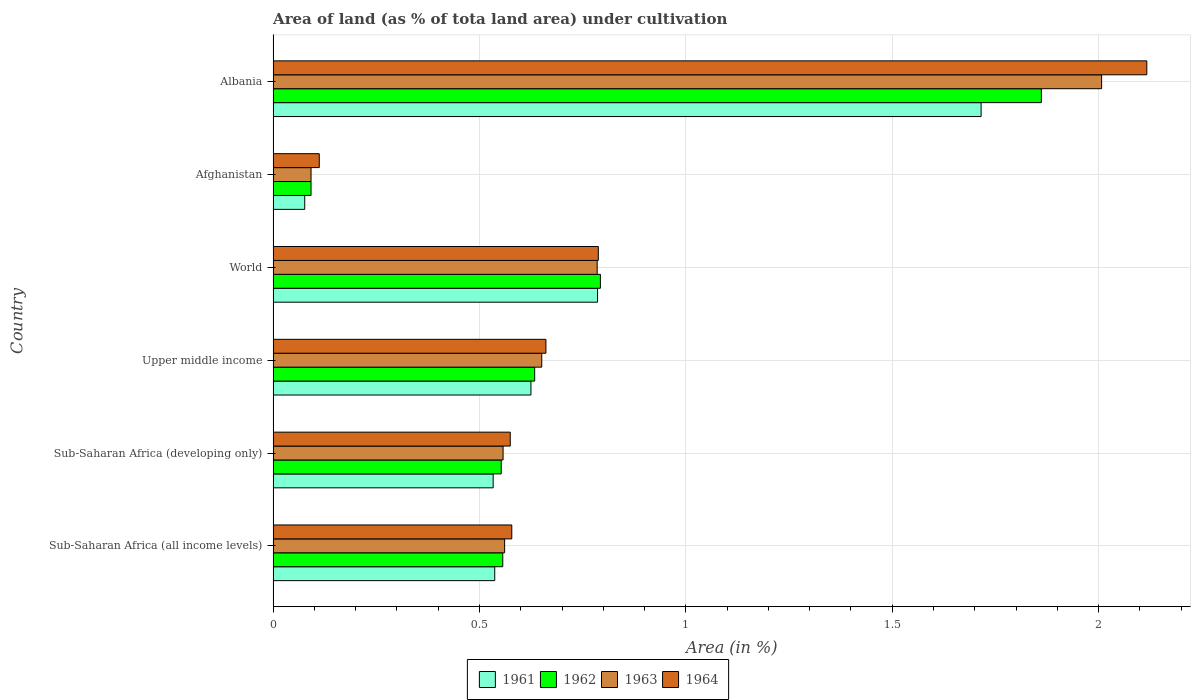How many different coloured bars are there?
Give a very brief answer. 4. Are the number of bars per tick equal to the number of legend labels?
Provide a succinct answer. Yes. Are the number of bars on each tick of the Y-axis equal?
Provide a succinct answer. Yes. What is the label of the 2nd group of bars from the top?
Your answer should be compact. Afghanistan. What is the percentage of land under cultivation in 1961 in Albania?
Give a very brief answer. 1.72. Across all countries, what is the maximum percentage of land under cultivation in 1961?
Provide a short and direct response. 1.72. Across all countries, what is the minimum percentage of land under cultivation in 1964?
Your answer should be very brief. 0.11. In which country was the percentage of land under cultivation in 1962 maximum?
Make the answer very short. Albania. In which country was the percentage of land under cultivation in 1964 minimum?
Give a very brief answer. Afghanistan. What is the total percentage of land under cultivation in 1964 in the graph?
Offer a very short reply. 4.83. What is the difference between the percentage of land under cultivation in 1961 in Albania and that in Sub-Saharan Africa (all income levels)?
Provide a short and direct response. 1.18. What is the difference between the percentage of land under cultivation in 1961 in Sub-Saharan Africa (all income levels) and the percentage of land under cultivation in 1962 in Sub-Saharan Africa (developing only)?
Offer a terse response. -0.02. What is the average percentage of land under cultivation in 1961 per country?
Provide a short and direct response. 0.71. What is the difference between the percentage of land under cultivation in 1961 and percentage of land under cultivation in 1963 in Afghanistan?
Keep it short and to the point. -0.02. What is the ratio of the percentage of land under cultivation in 1963 in Sub-Saharan Africa (developing only) to that in World?
Make the answer very short. 0.71. Is the difference between the percentage of land under cultivation in 1961 in Afghanistan and Sub-Saharan Africa (developing only) greater than the difference between the percentage of land under cultivation in 1963 in Afghanistan and Sub-Saharan Africa (developing only)?
Your answer should be very brief. Yes. What is the difference between the highest and the second highest percentage of land under cultivation in 1961?
Keep it short and to the point. 0.93. What is the difference between the highest and the lowest percentage of land under cultivation in 1962?
Offer a very short reply. 1.77. Is the sum of the percentage of land under cultivation in 1964 in Afghanistan and World greater than the maximum percentage of land under cultivation in 1962 across all countries?
Ensure brevity in your answer.  No. How many countries are there in the graph?
Provide a short and direct response. 6. What is the difference between two consecutive major ticks on the X-axis?
Your answer should be compact. 0.5. Are the values on the major ticks of X-axis written in scientific E-notation?
Provide a succinct answer. No. How many legend labels are there?
Your answer should be very brief. 4. What is the title of the graph?
Keep it short and to the point. Area of land (as % of tota land area) under cultivation. What is the label or title of the X-axis?
Offer a terse response. Area (in %). What is the Area (in %) of 1961 in Sub-Saharan Africa (all income levels)?
Offer a terse response. 0.54. What is the Area (in %) in 1962 in Sub-Saharan Africa (all income levels)?
Give a very brief answer. 0.56. What is the Area (in %) in 1963 in Sub-Saharan Africa (all income levels)?
Provide a succinct answer. 0.56. What is the Area (in %) of 1964 in Sub-Saharan Africa (all income levels)?
Ensure brevity in your answer.  0.58. What is the Area (in %) in 1961 in Sub-Saharan Africa (developing only)?
Keep it short and to the point. 0.53. What is the Area (in %) in 1962 in Sub-Saharan Africa (developing only)?
Keep it short and to the point. 0.55. What is the Area (in %) in 1963 in Sub-Saharan Africa (developing only)?
Your response must be concise. 0.56. What is the Area (in %) of 1964 in Sub-Saharan Africa (developing only)?
Your answer should be compact. 0.57. What is the Area (in %) of 1961 in Upper middle income?
Your answer should be very brief. 0.62. What is the Area (in %) in 1962 in Upper middle income?
Give a very brief answer. 0.63. What is the Area (in %) of 1963 in Upper middle income?
Keep it short and to the point. 0.65. What is the Area (in %) in 1964 in Upper middle income?
Give a very brief answer. 0.66. What is the Area (in %) in 1961 in World?
Your answer should be very brief. 0.79. What is the Area (in %) in 1962 in World?
Give a very brief answer. 0.79. What is the Area (in %) of 1963 in World?
Your answer should be compact. 0.79. What is the Area (in %) of 1964 in World?
Provide a short and direct response. 0.79. What is the Area (in %) in 1961 in Afghanistan?
Keep it short and to the point. 0.08. What is the Area (in %) of 1962 in Afghanistan?
Provide a succinct answer. 0.09. What is the Area (in %) in 1963 in Afghanistan?
Your answer should be very brief. 0.09. What is the Area (in %) in 1964 in Afghanistan?
Your answer should be compact. 0.11. What is the Area (in %) of 1961 in Albania?
Ensure brevity in your answer.  1.72. What is the Area (in %) of 1962 in Albania?
Ensure brevity in your answer.  1.86. What is the Area (in %) of 1963 in Albania?
Your answer should be compact. 2.01. What is the Area (in %) of 1964 in Albania?
Offer a very short reply. 2.12. Across all countries, what is the maximum Area (in %) of 1961?
Give a very brief answer. 1.72. Across all countries, what is the maximum Area (in %) in 1962?
Give a very brief answer. 1.86. Across all countries, what is the maximum Area (in %) in 1963?
Offer a terse response. 2.01. Across all countries, what is the maximum Area (in %) of 1964?
Your answer should be very brief. 2.12. Across all countries, what is the minimum Area (in %) in 1961?
Make the answer very short. 0.08. Across all countries, what is the minimum Area (in %) of 1962?
Keep it short and to the point. 0.09. Across all countries, what is the minimum Area (in %) of 1963?
Your response must be concise. 0.09. Across all countries, what is the minimum Area (in %) of 1964?
Make the answer very short. 0.11. What is the total Area (in %) of 1961 in the graph?
Provide a short and direct response. 4.27. What is the total Area (in %) of 1962 in the graph?
Keep it short and to the point. 4.49. What is the total Area (in %) in 1963 in the graph?
Give a very brief answer. 4.65. What is the total Area (in %) of 1964 in the graph?
Make the answer very short. 4.83. What is the difference between the Area (in %) in 1961 in Sub-Saharan Africa (all income levels) and that in Sub-Saharan Africa (developing only)?
Your response must be concise. 0. What is the difference between the Area (in %) of 1962 in Sub-Saharan Africa (all income levels) and that in Sub-Saharan Africa (developing only)?
Offer a very short reply. 0. What is the difference between the Area (in %) in 1963 in Sub-Saharan Africa (all income levels) and that in Sub-Saharan Africa (developing only)?
Provide a succinct answer. 0. What is the difference between the Area (in %) of 1964 in Sub-Saharan Africa (all income levels) and that in Sub-Saharan Africa (developing only)?
Give a very brief answer. 0. What is the difference between the Area (in %) in 1961 in Sub-Saharan Africa (all income levels) and that in Upper middle income?
Your answer should be compact. -0.09. What is the difference between the Area (in %) of 1962 in Sub-Saharan Africa (all income levels) and that in Upper middle income?
Ensure brevity in your answer.  -0.08. What is the difference between the Area (in %) of 1963 in Sub-Saharan Africa (all income levels) and that in Upper middle income?
Provide a short and direct response. -0.09. What is the difference between the Area (in %) in 1964 in Sub-Saharan Africa (all income levels) and that in Upper middle income?
Your answer should be compact. -0.08. What is the difference between the Area (in %) of 1961 in Sub-Saharan Africa (all income levels) and that in World?
Ensure brevity in your answer.  -0.25. What is the difference between the Area (in %) in 1962 in Sub-Saharan Africa (all income levels) and that in World?
Give a very brief answer. -0.24. What is the difference between the Area (in %) in 1963 in Sub-Saharan Africa (all income levels) and that in World?
Give a very brief answer. -0.22. What is the difference between the Area (in %) of 1964 in Sub-Saharan Africa (all income levels) and that in World?
Provide a succinct answer. -0.21. What is the difference between the Area (in %) in 1961 in Sub-Saharan Africa (all income levels) and that in Afghanistan?
Make the answer very short. 0.46. What is the difference between the Area (in %) of 1962 in Sub-Saharan Africa (all income levels) and that in Afghanistan?
Make the answer very short. 0.46. What is the difference between the Area (in %) in 1963 in Sub-Saharan Africa (all income levels) and that in Afghanistan?
Make the answer very short. 0.47. What is the difference between the Area (in %) in 1964 in Sub-Saharan Africa (all income levels) and that in Afghanistan?
Your answer should be compact. 0.47. What is the difference between the Area (in %) in 1961 in Sub-Saharan Africa (all income levels) and that in Albania?
Offer a very short reply. -1.18. What is the difference between the Area (in %) of 1962 in Sub-Saharan Africa (all income levels) and that in Albania?
Give a very brief answer. -1.3. What is the difference between the Area (in %) in 1963 in Sub-Saharan Africa (all income levels) and that in Albania?
Offer a terse response. -1.45. What is the difference between the Area (in %) in 1964 in Sub-Saharan Africa (all income levels) and that in Albania?
Give a very brief answer. -1.54. What is the difference between the Area (in %) of 1961 in Sub-Saharan Africa (developing only) and that in Upper middle income?
Your answer should be compact. -0.09. What is the difference between the Area (in %) in 1962 in Sub-Saharan Africa (developing only) and that in Upper middle income?
Make the answer very short. -0.08. What is the difference between the Area (in %) of 1963 in Sub-Saharan Africa (developing only) and that in Upper middle income?
Ensure brevity in your answer.  -0.09. What is the difference between the Area (in %) of 1964 in Sub-Saharan Africa (developing only) and that in Upper middle income?
Your answer should be compact. -0.09. What is the difference between the Area (in %) in 1961 in Sub-Saharan Africa (developing only) and that in World?
Your response must be concise. -0.25. What is the difference between the Area (in %) of 1962 in Sub-Saharan Africa (developing only) and that in World?
Make the answer very short. -0.24. What is the difference between the Area (in %) in 1963 in Sub-Saharan Africa (developing only) and that in World?
Your answer should be very brief. -0.23. What is the difference between the Area (in %) in 1964 in Sub-Saharan Africa (developing only) and that in World?
Give a very brief answer. -0.21. What is the difference between the Area (in %) in 1961 in Sub-Saharan Africa (developing only) and that in Afghanistan?
Ensure brevity in your answer.  0.46. What is the difference between the Area (in %) in 1962 in Sub-Saharan Africa (developing only) and that in Afghanistan?
Give a very brief answer. 0.46. What is the difference between the Area (in %) in 1963 in Sub-Saharan Africa (developing only) and that in Afghanistan?
Your answer should be compact. 0.47. What is the difference between the Area (in %) of 1964 in Sub-Saharan Africa (developing only) and that in Afghanistan?
Provide a succinct answer. 0.46. What is the difference between the Area (in %) in 1961 in Sub-Saharan Africa (developing only) and that in Albania?
Make the answer very short. -1.18. What is the difference between the Area (in %) of 1962 in Sub-Saharan Africa (developing only) and that in Albania?
Your answer should be compact. -1.31. What is the difference between the Area (in %) in 1963 in Sub-Saharan Africa (developing only) and that in Albania?
Offer a very short reply. -1.45. What is the difference between the Area (in %) in 1964 in Sub-Saharan Africa (developing only) and that in Albania?
Your answer should be very brief. -1.54. What is the difference between the Area (in %) in 1961 in Upper middle income and that in World?
Give a very brief answer. -0.16. What is the difference between the Area (in %) in 1962 in Upper middle income and that in World?
Give a very brief answer. -0.16. What is the difference between the Area (in %) of 1963 in Upper middle income and that in World?
Offer a terse response. -0.13. What is the difference between the Area (in %) of 1964 in Upper middle income and that in World?
Provide a short and direct response. -0.13. What is the difference between the Area (in %) in 1961 in Upper middle income and that in Afghanistan?
Ensure brevity in your answer.  0.55. What is the difference between the Area (in %) of 1962 in Upper middle income and that in Afghanistan?
Your answer should be very brief. 0.54. What is the difference between the Area (in %) of 1963 in Upper middle income and that in Afghanistan?
Provide a succinct answer. 0.56. What is the difference between the Area (in %) in 1964 in Upper middle income and that in Afghanistan?
Your answer should be very brief. 0.55. What is the difference between the Area (in %) of 1961 in Upper middle income and that in Albania?
Ensure brevity in your answer.  -1.09. What is the difference between the Area (in %) in 1962 in Upper middle income and that in Albania?
Provide a short and direct response. -1.23. What is the difference between the Area (in %) in 1963 in Upper middle income and that in Albania?
Your answer should be very brief. -1.36. What is the difference between the Area (in %) in 1964 in Upper middle income and that in Albania?
Provide a succinct answer. -1.46. What is the difference between the Area (in %) of 1961 in World and that in Afghanistan?
Keep it short and to the point. 0.71. What is the difference between the Area (in %) of 1962 in World and that in Afghanistan?
Your answer should be very brief. 0.7. What is the difference between the Area (in %) in 1963 in World and that in Afghanistan?
Provide a short and direct response. 0.69. What is the difference between the Area (in %) in 1964 in World and that in Afghanistan?
Your answer should be compact. 0.68. What is the difference between the Area (in %) of 1961 in World and that in Albania?
Your answer should be compact. -0.93. What is the difference between the Area (in %) in 1962 in World and that in Albania?
Make the answer very short. -1.07. What is the difference between the Area (in %) of 1963 in World and that in Albania?
Your answer should be very brief. -1.22. What is the difference between the Area (in %) of 1964 in World and that in Albania?
Your answer should be very brief. -1.33. What is the difference between the Area (in %) of 1961 in Afghanistan and that in Albania?
Your answer should be very brief. -1.64. What is the difference between the Area (in %) in 1962 in Afghanistan and that in Albania?
Your answer should be very brief. -1.77. What is the difference between the Area (in %) of 1963 in Afghanistan and that in Albania?
Your response must be concise. -1.92. What is the difference between the Area (in %) in 1964 in Afghanistan and that in Albania?
Provide a short and direct response. -2. What is the difference between the Area (in %) in 1961 in Sub-Saharan Africa (all income levels) and the Area (in %) in 1962 in Sub-Saharan Africa (developing only)?
Make the answer very short. -0.02. What is the difference between the Area (in %) of 1961 in Sub-Saharan Africa (all income levels) and the Area (in %) of 1963 in Sub-Saharan Africa (developing only)?
Your answer should be compact. -0.02. What is the difference between the Area (in %) of 1961 in Sub-Saharan Africa (all income levels) and the Area (in %) of 1964 in Sub-Saharan Africa (developing only)?
Give a very brief answer. -0.04. What is the difference between the Area (in %) in 1962 in Sub-Saharan Africa (all income levels) and the Area (in %) in 1963 in Sub-Saharan Africa (developing only)?
Ensure brevity in your answer.  -0. What is the difference between the Area (in %) of 1962 in Sub-Saharan Africa (all income levels) and the Area (in %) of 1964 in Sub-Saharan Africa (developing only)?
Your response must be concise. -0.02. What is the difference between the Area (in %) in 1963 in Sub-Saharan Africa (all income levels) and the Area (in %) in 1964 in Sub-Saharan Africa (developing only)?
Your answer should be very brief. -0.01. What is the difference between the Area (in %) in 1961 in Sub-Saharan Africa (all income levels) and the Area (in %) in 1962 in Upper middle income?
Offer a terse response. -0.1. What is the difference between the Area (in %) of 1961 in Sub-Saharan Africa (all income levels) and the Area (in %) of 1963 in Upper middle income?
Your answer should be compact. -0.11. What is the difference between the Area (in %) in 1961 in Sub-Saharan Africa (all income levels) and the Area (in %) in 1964 in Upper middle income?
Your response must be concise. -0.12. What is the difference between the Area (in %) in 1962 in Sub-Saharan Africa (all income levels) and the Area (in %) in 1963 in Upper middle income?
Make the answer very short. -0.09. What is the difference between the Area (in %) of 1962 in Sub-Saharan Africa (all income levels) and the Area (in %) of 1964 in Upper middle income?
Offer a terse response. -0.1. What is the difference between the Area (in %) in 1963 in Sub-Saharan Africa (all income levels) and the Area (in %) in 1964 in Upper middle income?
Provide a short and direct response. -0.1. What is the difference between the Area (in %) of 1961 in Sub-Saharan Africa (all income levels) and the Area (in %) of 1962 in World?
Provide a short and direct response. -0.26. What is the difference between the Area (in %) of 1961 in Sub-Saharan Africa (all income levels) and the Area (in %) of 1963 in World?
Provide a short and direct response. -0.25. What is the difference between the Area (in %) of 1961 in Sub-Saharan Africa (all income levels) and the Area (in %) of 1964 in World?
Your answer should be very brief. -0.25. What is the difference between the Area (in %) of 1962 in Sub-Saharan Africa (all income levels) and the Area (in %) of 1963 in World?
Make the answer very short. -0.23. What is the difference between the Area (in %) of 1962 in Sub-Saharan Africa (all income levels) and the Area (in %) of 1964 in World?
Give a very brief answer. -0.23. What is the difference between the Area (in %) in 1963 in Sub-Saharan Africa (all income levels) and the Area (in %) in 1964 in World?
Offer a very short reply. -0.23. What is the difference between the Area (in %) in 1961 in Sub-Saharan Africa (all income levels) and the Area (in %) in 1962 in Afghanistan?
Your response must be concise. 0.45. What is the difference between the Area (in %) of 1961 in Sub-Saharan Africa (all income levels) and the Area (in %) of 1963 in Afghanistan?
Offer a terse response. 0.45. What is the difference between the Area (in %) of 1961 in Sub-Saharan Africa (all income levels) and the Area (in %) of 1964 in Afghanistan?
Keep it short and to the point. 0.43. What is the difference between the Area (in %) in 1962 in Sub-Saharan Africa (all income levels) and the Area (in %) in 1963 in Afghanistan?
Your response must be concise. 0.46. What is the difference between the Area (in %) of 1962 in Sub-Saharan Africa (all income levels) and the Area (in %) of 1964 in Afghanistan?
Your answer should be compact. 0.44. What is the difference between the Area (in %) of 1963 in Sub-Saharan Africa (all income levels) and the Area (in %) of 1964 in Afghanistan?
Your answer should be compact. 0.45. What is the difference between the Area (in %) of 1961 in Sub-Saharan Africa (all income levels) and the Area (in %) of 1962 in Albania?
Provide a short and direct response. -1.32. What is the difference between the Area (in %) of 1961 in Sub-Saharan Africa (all income levels) and the Area (in %) of 1963 in Albania?
Your answer should be compact. -1.47. What is the difference between the Area (in %) of 1961 in Sub-Saharan Africa (all income levels) and the Area (in %) of 1964 in Albania?
Give a very brief answer. -1.58. What is the difference between the Area (in %) in 1962 in Sub-Saharan Africa (all income levels) and the Area (in %) in 1963 in Albania?
Your response must be concise. -1.45. What is the difference between the Area (in %) of 1962 in Sub-Saharan Africa (all income levels) and the Area (in %) of 1964 in Albania?
Offer a very short reply. -1.56. What is the difference between the Area (in %) in 1963 in Sub-Saharan Africa (all income levels) and the Area (in %) in 1964 in Albania?
Your response must be concise. -1.56. What is the difference between the Area (in %) in 1961 in Sub-Saharan Africa (developing only) and the Area (in %) in 1962 in Upper middle income?
Offer a very short reply. -0.1. What is the difference between the Area (in %) of 1961 in Sub-Saharan Africa (developing only) and the Area (in %) of 1963 in Upper middle income?
Provide a short and direct response. -0.12. What is the difference between the Area (in %) in 1961 in Sub-Saharan Africa (developing only) and the Area (in %) in 1964 in Upper middle income?
Keep it short and to the point. -0.13. What is the difference between the Area (in %) in 1962 in Sub-Saharan Africa (developing only) and the Area (in %) in 1963 in Upper middle income?
Your response must be concise. -0.1. What is the difference between the Area (in %) in 1962 in Sub-Saharan Africa (developing only) and the Area (in %) in 1964 in Upper middle income?
Ensure brevity in your answer.  -0.11. What is the difference between the Area (in %) of 1963 in Sub-Saharan Africa (developing only) and the Area (in %) of 1964 in Upper middle income?
Ensure brevity in your answer.  -0.1. What is the difference between the Area (in %) in 1961 in Sub-Saharan Africa (developing only) and the Area (in %) in 1962 in World?
Give a very brief answer. -0.26. What is the difference between the Area (in %) in 1961 in Sub-Saharan Africa (developing only) and the Area (in %) in 1963 in World?
Your response must be concise. -0.25. What is the difference between the Area (in %) of 1961 in Sub-Saharan Africa (developing only) and the Area (in %) of 1964 in World?
Offer a terse response. -0.25. What is the difference between the Area (in %) of 1962 in Sub-Saharan Africa (developing only) and the Area (in %) of 1963 in World?
Provide a succinct answer. -0.23. What is the difference between the Area (in %) of 1962 in Sub-Saharan Africa (developing only) and the Area (in %) of 1964 in World?
Give a very brief answer. -0.24. What is the difference between the Area (in %) of 1963 in Sub-Saharan Africa (developing only) and the Area (in %) of 1964 in World?
Offer a terse response. -0.23. What is the difference between the Area (in %) in 1961 in Sub-Saharan Africa (developing only) and the Area (in %) in 1962 in Afghanistan?
Offer a terse response. 0.44. What is the difference between the Area (in %) of 1961 in Sub-Saharan Africa (developing only) and the Area (in %) of 1963 in Afghanistan?
Offer a terse response. 0.44. What is the difference between the Area (in %) in 1961 in Sub-Saharan Africa (developing only) and the Area (in %) in 1964 in Afghanistan?
Your response must be concise. 0.42. What is the difference between the Area (in %) of 1962 in Sub-Saharan Africa (developing only) and the Area (in %) of 1963 in Afghanistan?
Provide a short and direct response. 0.46. What is the difference between the Area (in %) in 1962 in Sub-Saharan Africa (developing only) and the Area (in %) in 1964 in Afghanistan?
Your answer should be very brief. 0.44. What is the difference between the Area (in %) of 1963 in Sub-Saharan Africa (developing only) and the Area (in %) of 1964 in Afghanistan?
Offer a very short reply. 0.45. What is the difference between the Area (in %) of 1961 in Sub-Saharan Africa (developing only) and the Area (in %) of 1962 in Albania?
Provide a short and direct response. -1.33. What is the difference between the Area (in %) in 1961 in Sub-Saharan Africa (developing only) and the Area (in %) in 1963 in Albania?
Offer a terse response. -1.47. What is the difference between the Area (in %) in 1961 in Sub-Saharan Africa (developing only) and the Area (in %) in 1964 in Albania?
Give a very brief answer. -1.58. What is the difference between the Area (in %) of 1962 in Sub-Saharan Africa (developing only) and the Area (in %) of 1963 in Albania?
Ensure brevity in your answer.  -1.45. What is the difference between the Area (in %) in 1962 in Sub-Saharan Africa (developing only) and the Area (in %) in 1964 in Albania?
Give a very brief answer. -1.56. What is the difference between the Area (in %) in 1963 in Sub-Saharan Africa (developing only) and the Area (in %) in 1964 in Albania?
Your response must be concise. -1.56. What is the difference between the Area (in %) in 1961 in Upper middle income and the Area (in %) in 1962 in World?
Offer a very short reply. -0.17. What is the difference between the Area (in %) of 1961 in Upper middle income and the Area (in %) of 1963 in World?
Your response must be concise. -0.16. What is the difference between the Area (in %) of 1961 in Upper middle income and the Area (in %) of 1964 in World?
Ensure brevity in your answer.  -0.16. What is the difference between the Area (in %) in 1962 in Upper middle income and the Area (in %) in 1963 in World?
Your answer should be compact. -0.15. What is the difference between the Area (in %) of 1962 in Upper middle income and the Area (in %) of 1964 in World?
Provide a short and direct response. -0.15. What is the difference between the Area (in %) in 1963 in Upper middle income and the Area (in %) in 1964 in World?
Offer a very short reply. -0.14. What is the difference between the Area (in %) in 1961 in Upper middle income and the Area (in %) in 1962 in Afghanistan?
Provide a short and direct response. 0.53. What is the difference between the Area (in %) of 1961 in Upper middle income and the Area (in %) of 1963 in Afghanistan?
Keep it short and to the point. 0.53. What is the difference between the Area (in %) of 1961 in Upper middle income and the Area (in %) of 1964 in Afghanistan?
Your answer should be compact. 0.51. What is the difference between the Area (in %) in 1962 in Upper middle income and the Area (in %) in 1963 in Afghanistan?
Provide a succinct answer. 0.54. What is the difference between the Area (in %) in 1962 in Upper middle income and the Area (in %) in 1964 in Afghanistan?
Offer a terse response. 0.52. What is the difference between the Area (in %) of 1963 in Upper middle income and the Area (in %) of 1964 in Afghanistan?
Give a very brief answer. 0.54. What is the difference between the Area (in %) in 1961 in Upper middle income and the Area (in %) in 1962 in Albania?
Give a very brief answer. -1.24. What is the difference between the Area (in %) of 1961 in Upper middle income and the Area (in %) of 1963 in Albania?
Your response must be concise. -1.38. What is the difference between the Area (in %) in 1961 in Upper middle income and the Area (in %) in 1964 in Albania?
Offer a very short reply. -1.49. What is the difference between the Area (in %) in 1962 in Upper middle income and the Area (in %) in 1963 in Albania?
Give a very brief answer. -1.37. What is the difference between the Area (in %) of 1962 in Upper middle income and the Area (in %) of 1964 in Albania?
Your response must be concise. -1.48. What is the difference between the Area (in %) of 1963 in Upper middle income and the Area (in %) of 1964 in Albania?
Your response must be concise. -1.47. What is the difference between the Area (in %) in 1961 in World and the Area (in %) in 1962 in Afghanistan?
Keep it short and to the point. 0.69. What is the difference between the Area (in %) of 1961 in World and the Area (in %) of 1963 in Afghanistan?
Ensure brevity in your answer.  0.69. What is the difference between the Area (in %) of 1961 in World and the Area (in %) of 1964 in Afghanistan?
Offer a very short reply. 0.67. What is the difference between the Area (in %) of 1962 in World and the Area (in %) of 1963 in Afghanistan?
Your response must be concise. 0.7. What is the difference between the Area (in %) in 1962 in World and the Area (in %) in 1964 in Afghanistan?
Ensure brevity in your answer.  0.68. What is the difference between the Area (in %) in 1963 in World and the Area (in %) in 1964 in Afghanistan?
Your answer should be compact. 0.67. What is the difference between the Area (in %) in 1961 in World and the Area (in %) in 1962 in Albania?
Your response must be concise. -1.08. What is the difference between the Area (in %) in 1961 in World and the Area (in %) in 1963 in Albania?
Offer a very short reply. -1.22. What is the difference between the Area (in %) in 1961 in World and the Area (in %) in 1964 in Albania?
Give a very brief answer. -1.33. What is the difference between the Area (in %) of 1962 in World and the Area (in %) of 1963 in Albania?
Your response must be concise. -1.21. What is the difference between the Area (in %) of 1962 in World and the Area (in %) of 1964 in Albania?
Make the answer very short. -1.32. What is the difference between the Area (in %) of 1963 in World and the Area (in %) of 1964 in Albania?
Keep it short and to the point. -1.33. What is the difference between the Area (in %) of 1961 in Afghanistan and the Area (in %) of 1962 in Albania?
Your response must be concise. -1.78. What is the difference between the Area (in %) of 1961 in Afghanistan and the Area (in %) of 1963 in Albania?
Provide a short and direct response. -1.93. What is the difference between the Area (in %) of 1961 in Afghanistan and the Area (in %) of 1964 in Albania?
Ensure brevity in your answer.  -2.04. What is the difference between the Area (in %) of 1962 in Afghanistan and the Area (in %) of 1963 in Albania?
Offer a terse response. -1.92. What is the difference between the Area (in %) in 1962 in Afghanistan and the Area (in %) in 1964 in Albania?
Your answer should be very brief. -2.02. What is the difference between the Area (in %) in 1963 in Afghanistan and the Area (in %) in 1964 in Albania?
Your answer should be compact. -2.02. What is the average Area (in %) in 1961 per country?
Give a very brief answer. 0.71. What is the average Area (in %) of 1962 per country?
Offer a very short reply. 0.75. What is the average Area (in %) in 1963 per country?
Your answer should be compact. 0.78. What is the average Area (in %) of 1964 per country?
Give a very brief answer. 0.81. What is the difference between the Area (in %) in 1961 and Area (in %) in 1962 in Sub-Saharan Africa (all income levels)?
Your answer should be very brief. -0.02. What is the difference between the Area (in %) in 1961 and Area (in %) in 1963 in Sub-Saharan Africa (all income levels)?
Your answer should be compact. -0.02. What is the difference between the Area (in %) of 1961 and Area (in %) of 1964 in Sub-Saharan Africa (all income levels)?
Your response must be concise. -0.04. What is the difference between the Area (in %) of 1962 and Area (in %) of 1963 in Sub-Saharan Africa (all income levels)?
Offer a very short reply. -0. What is the difference between the Area (in %) of 1962 and Area (in %) of 1964 in Sub-Saharan Africa (all income levels)?
Your answer should be very brief. -0.02. What is the difference between the Area (in %) of 1963 and Area (in %) of 1964 in Sub-Saharan Africa (all income levels)?
Make the answer very short. -0.02. What is the difference between the Area (in %) in 1961 and Area (in %) in 1962 in Sub-Saharan Africa (developing only)?
Make the answer very short. -0.02. What is the difference between the Area (in %) in 1961 and Area (in %) in 1963 in Sub-Saharan Africa (developing only)?
Provide a short and direct response. -0.02. What is the difference between the Area (in %) in 1961 and Area (in %) in 1964 in Sub-Saharan Africa (developing only)?
Offer a very short reply. -0.04. What is the difference between the Area (in %) in 1962 and Area (in %) in 1963 in Sub-Saharan Africa (developing only)?
Your answer should be very brief. -0. What is the difference between the Area (in %) of 1962 and Area (in %) of 1964 in Sub-Saharan Africa (developing only)?
Give a very brief answer. -0.02. What is the difference between the Area (in %) in 1963 and Area (in %) in 1964 in Sub-Saharan Africa (developing only)?
Give a very brief answer. -0.02. What is the difference between the Area (in %) of 1961 and Area (in %) of 1962 in Upper middle income?
Offer a terse response. -0.01. What is the difference between the Area (in %) in 1961 and Area (in %) in 1963 in Upper middle income?
Offer a terse response. -0.03. What is the difference between the Area (in %) of 1961 and Area (in %) of 1964 in Upper middle income?
Make the answer very short. -0.04. What is the difference between the Area (in %) of 1962 and Area (in %) of 1963 in Upper middle income?
Keep it short and to the point. -0.02. What is the difference between the Area (in %) in 1962 and Area (in %) in 1964 in Upper middle income?
Make the answer very short. -0.03. What is the difference between the Area (in %) in 1963 and Area (in %) in 1964 in Upper middle income?
Give a very brief answer. -0.01. What is the difference between the Area (in %) in 1961 and Area (in %) in 1962 in World?
Give a very brief answer. -0.01. What is the difference between the Area (in %) of 1961 and Area (in %) of 1963 in World?
Ensure brevity in your answer.  0. What is the difference between the Area (in %) in 1961 and Area (in %) in 1964 in World?
Keep it short and to the point. -0. What is the difference between the Area (in %) of 1962 and Area (in %) of 1963 in World?
Make the answer very short. 0.01. What is the difference between the Area (in %) of 1962 and Area (in %) of 1964 in World?
Make the answer very short. 0.01. What is the difference between the Area (in %) of 1963 and Area (in %) of 1964 in World?
Provide a succinct answer. -0. What is the difference between the Area (in %) in 1961 and Area (in %) in 1962 in Afghanistan?
Offer a terse response. -0.02. What is the difference between the Area (in %) in 1961 and Area (in %) in 1963 in Afghanistan?
Offer a very short reply. -0.02. What is the difference between the Area (in %) in 1961 and Area (in %) in 1964 in Afghanistan?
Offer a very short reply. -0.04. What is the difference between the Area (in %) of 1962 and Area (in %) of 1963 in Afghanistan?
Your response must be concise. 0. What is the difference between the Area (in %) in 1962 and Area (in %) in 1964 in Afghanistan?
Make the answer very short. -0.02. What is the difference between the Area (in %) in 1963 and Area (in %) in 1964 in Afghanistan?
Provide a succinct answer. -0.02. What is the difference between the Area (in %) in 1961 and Area (in %) in 1962 in Albania?
Keep it short and to the point. -0.15. What is the difference between the Area (in %) of 1961 and Area (in %) of 1963 in Albania?
Provide a short and direct response. -0.29. What is the difference between the Area (in %) in 1961 and Area (in %) in 1964 in Albania?
Give a very brief answer. -0.4. What is the difference between the Area (in %) in 1962 and Area (in %) in 1963 in Albania?
Your answer should be compact. -0.15. What is the difference between the Area (in %) in 1962 and Area (in %) in 1964 in Albania?
Your answer should be very brief. -0.26. What is the difference between the Area (in %) in 1963 and Area (in %) in 1964 in Albania?
Provide a short and direct response. -0.11. What is the ratio of the Area (in %) in 1961 in Sub-Saharan Africa (all income levels) to that in Sub-Saharan Africa (developing only)?
Provide a short and direct response. 1.01. What is the ratio of the Area (in %) of 1962 in Sub-Saharan Africa (all income levels) to that in Sub-Saharan Africa (developing only)?
Your answer should be compact. 1.01. What is the ratio of the Area (in %) of 1961 in Sub-Saharan Africa (all income levels) to that in Upper middle income?
Make the answer very short. 0.86. What is the ratio of the Area (in %) in 1962 in Sub-Saharan Africa (all income levels) to that in Upper middle income?
Ensure brevity in your answer.  0.88. What is the ratio of the Area (in %) in 1963 in Sub-Saharan Africa (all income levels) to that in Upper middle income?
Make the answer very short. 0.86. What is the ratio of the Area (in %) in 1964 in Sub-Saharan Africa (all income levels) to that in Upper middle income?
Your answer should be compact. 0.87. What is the ratio of the Area (in %) of 1961 in Sub-Saharan Africa (all income levels) to that in World?
Your answer should be compact. 0.68. What is the ratio of the Area (in %) of 1962 in Sub-Saharan Africa (all income levels) to that in World?
Provide a short and direct response. 0.7. What is the ratio of the Area (in %) in 1963 in Sub-Saharan Africa (all income levels) to that in World?
Keep it short and to the point. 0.71. What is the ratio of the Area (in %) of 1964 in Sub-Saharan Africa (all income levels) to that in World?
Make the answer very short. 0.73. What is the ratio of the Area (in %) of 1961 in Sub-Saharan Africa (all income levels) to that in Afghanistan?
Provide a short and direct response. 7.01. What is the ratio of the Area (in %) of 1962 in Sub-Saharan Africa (all income levels) to that in Afghanistan?
Ensure brevity in your answer.  6.05. What is the ratio of the Area (in %) in 1963 in Sub-Saharan Africa (all income levels) to that in Afghanistan?
Give a very brief answer. 6.1. What is the ratio of the Area (in %) in 1964 in Sub-Saharan Africa (all income levels) to that in Afghanistan?
Offer a very short reply. 5.17. What is the ratio of the Area (in %) in 1961 in Sub-Saharan Africa (all income levels) to that in Albania?
Your response must be concise. 0.31. What is the ratio of the Area (in %) of 1962 in Sub-Saharan Africa (all income levels) to that in Albania?
Ensure brevity in your answer.  0.3. What is the ratio of the Area (in %) in 1963 in Sub-Saharan Africa (all income levels) to that in Albania?
Your answer should be very brief. 0.28. What is the ratio of the Area (in %) in 1964 in Sub-Saharan Africa (all income levels) to that in Albania?
Offer a terse response. 0.27. What is the ratio of the Area (in %) of 1961 in Sub-Saharan Africa (developing only) to that in Upper middle income?
Offer a terse response. 0.85. What is the ratio of the Area (in %) of 1962 in Sub-Saharan Africa (developing only) to that in Upper middle income?
Make the answer very short. 0.87. What is the ratio of the Area (in %) in 1963 in Sub-Saharan Africa (developing only) to that in Upper middle income?
Provide a short and direct response. 0.86. What is the ratio of the Area (in %) of 1964 in Sub-Saharan Africa (developing only) to that in Upper middle income?
Your answer should be compact. 0.87. What is the ratio of the Area (in %) of 1961 in Sub-Saharan Africa (developing only) to that in World?
Offer a terse response. 0.68. What is the ratio of the Area (in %) in 1962 in Sub-Saharan Africa (developing only) to that in World?
Ensure brevity in your answer.  0.7. What is the ratio of the Area (in %) in 1963 in Sub-Saharan Africa (developing only) to that in World?
Provide a short and direct response. 0.71. What is the ratio of the Area (in %) in 1964 in Sub-Saharan Africa (developing only) to that in World?
Your answer should be compact. 0.73. What is the ratio of the Area (in %) in 1961 in Sub-Saharan Africa (developing only) to that in Afghanistan?
Give a very brief answer. 6.96. What is the ratio of the Area (in %) of 1962 in Sub-Saharan Africa (developing only) to that in Afghanistan?
Offer a terse response. 6.01. What is the ratio of the Area (in %) of 1963 in Sub-Saharan Africa (developing only) to that in Afghanistan?
Offer a very short reply. 6.06. What is the ratio of the Area (in %) of 1964 in Sub-Saharan Africa (developing only) to that in Afghanistan?
Offer a terse response. 5.14. What is the ratio of the Area (in %) of 1961 in Sub-Saharan Africa (developing only) to that in Albania?
Your response must be concise. 0.31. What is the ratio of the Area (in %) in 1962 in Sub-Saharan Africa (developing only) to that in Albania?
Offer a terse response. 0.3. What is the ratio of the Area (in %) in 1963 in Sub-Saharan Africa (developing only) to that in Albania?
Provide a short and direct response. 0.28. What is the ratio of the Area (in %) of 1964 in Sub-Saharan Africa (developing only) to that in Albania?
Your answer should be very brief. 0.27. What is the ratio of the Area (in %) in 1961 in Upper middle income to that in World?
Give a very brief answer. 0.79. What is the ratio of the Area (in %) of 1962 in Upper middle income to that in World?
Your answer should be compact. 0.8. What is the ratio of the Area (in %) in 1963 in Upper middle income to that in World?
Provide a succinct answer. 0.83. What is the ratio of the Area (in %) of 1964 in Upper middle income to that in World?
Your answer should be compact. 0.84. What is the ratio of the Area (in %) of 1961 in Upper middle income to that in Afghanistan?
Provide a succinct answer. 8.16. What is the ratio of the Area (in %) in 1962 in Upper middle income to that in Afghanistan?
Offer a very short reply. 6.9. What is the ratio of the Area (in %) in 1963 in Upper middle income to that in Afghanistan?
Make the answer very short. 7.08. What is the ratio of the Area (in %) in 1964 in Upper middle income to that in Afghanistan?
Make the answer very short. 5.91. What is the ratio of the Area (in %) of 1961 in Upper middle income to that in Albania?
Offer a very short reply. 0.36. What is the ratio of the Area (in %) in 1962 in Upper middle income to that in Albania?
Provide a short and direct response. 0.34. What is the ratio of the Area (in %) in 1963 in Upper middle income to that in Albania?
Make the answer very short. 0.32. What is the ratio of the Area (in %) of 1964 in Upper middle income to that in Albania?
Offer a terse response. 0.31. What is the ratio of the Area (in %) in 1961 in World to that in Afghanistan?
Your answer should be compact. 10.26. What is the ratio of the Area (in %) in 1962 in World to that in Afghanistan?
Your answer should be very brief. 8.63. What is the ratio of the Area (in %) of 1963 in World to that in Afghanistan?
Make the answer very short. 8.54. What is the ratio of the Area (in %) in 1964 in World to that in Afghanistan?
Your response must be concise. 7.05. What is the ratio of the Area (in %) of 1961 in World to that in Albania?
Ensure brevity in your answer.  0.46. What is the ratio of the Area (in %) in 1962 in World to that in Albania?
Keep it short and to the point. 0.43. What is the ratio of the Area (in %) in 1963 in World to that in Albania?
Keep it short and to the point. 0.39. What is the ratio of the Area (in %) in 1964 in World to that in Albania?
Offer a very short reply. 0.37. What is the ratio of the Area (in %) of 1961 in Afghanistan to that in Albania?
Provide a succinct answer. 0.04. What is the ratio of the Area (in %) of 1962 in Afghanistan to that in Albania?
Provide a succinct answer. 0.05. What is the ratio of the Area (in %) in 1963 in Afghanistan to that in Albania?
Offer a terse response. 0.05. What is the ratio of the Area (in %) in 1964 in Afghanistan to that in Albania?
Make the answer very short. 0.05. What is the difference between the highest and the second highest Area (in %) in 1961?
Ensure brevity in your answer.  0.93. What is the difference between the highest and the second highest Area (in %) in 1962?
Offer a very short reply. 1.07. What is the difference between the highest and the second highest Area (in %) in 1963?
Give a very brief answer. 1.22. What is the difference between the highest and the second highest Area (in %) in 1964?
Offer a very short reply. 1.33. What is the difference between the highest and the lowest Area (in %) of 1961?
Offer a very short reply. 1.64. What is the difference between the highest and the lowest Area (in %) in 1962?
Your answer should be compact. 1.77. What is the difference between the highest and the lowest Area (in %) of 1963?
Your answer should be very brief. 1.92. What is the difference between the highest and the lowest Area (in %) in 1964?
Offer a very short reply. 2. 